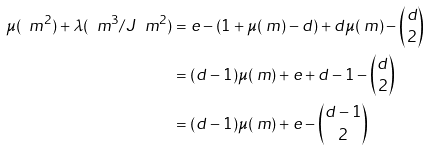Convert formula to latex. <formula><loc_0><loc_0><loc_500><loc_500>\mu ( \ m ^ { 2 } ) + \lambda ( \ m ^ { 3 } / J \ m ^ { 2 } ) & = e - ( 1 + \mu ( \ m ) - d ) + d \mu ( \ m ) - \binom { d } { 2 } \\ & = ( d - 1 ) \mu ( \ m ) + e + d - 1 - \binom { d } { 2 } \\ & = ( d - 1 ) \mu ( \ m ) + e - \binom { d - 1 } { 2 }</formula> 